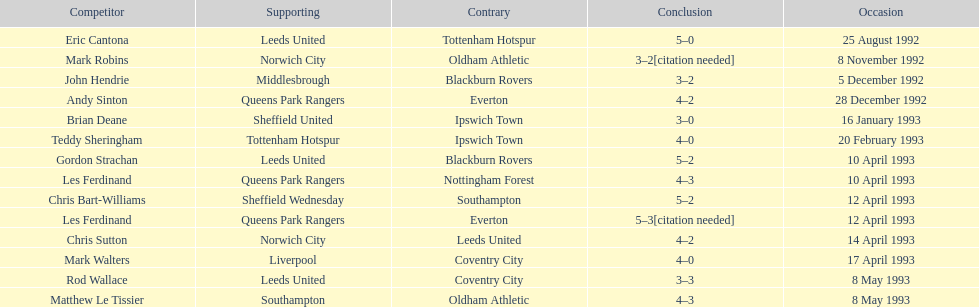Which team did liverpool play against? Coventry City. 